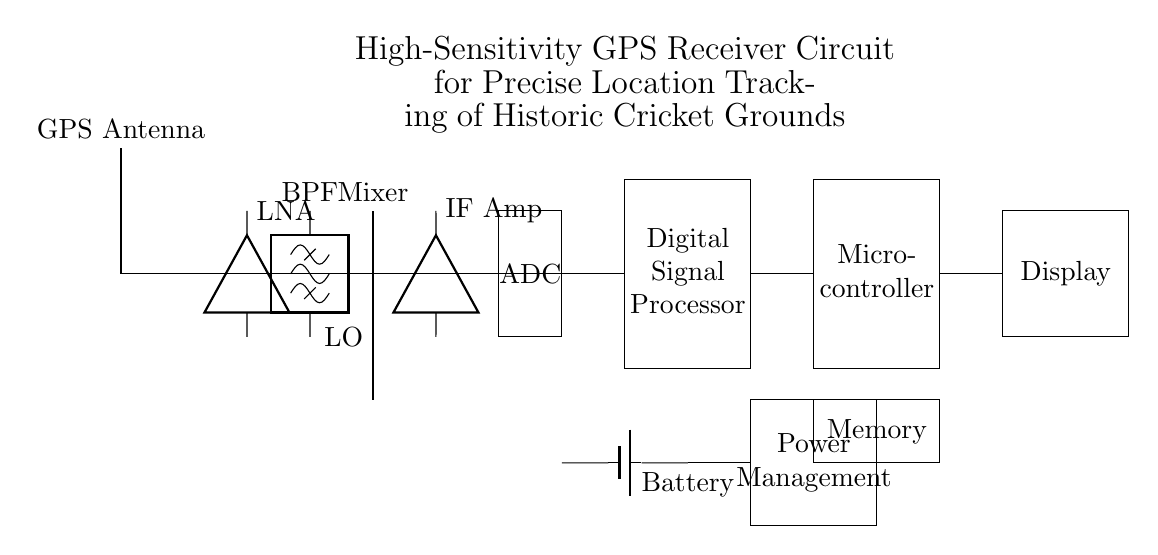What is the function of the LNA? The Low Noise Amplifier (LNA) is used to amplify the weak GPS signals received by the GPS antenna without adding significant noise. It ensures that the signals are strong enough for further processing in the circuit.
Answer: Amplification What type of filter is used in this circuit? The circuit includes a Bandpass Filter (BPF), which selectively allows the desired frequency range from the signals while rejecting others, thereby improving signal quality for further processing.
Answer: Bandpass Filter How many main components are in this GPS receiver circuit? The circuit diagram shows a total of eight main components: GPS Antenna, LNA, BPF, Mixer, Local Oscillator, IF Amplifier, ADC, Digital Signal Processor, and Microcontroller, along with supporting components like Memory, Display, and Power Management.
Answer: Eight Which component interfaces with the analog signals and digital systems? The ADC (Analog-to-Digital Converter) interfaces the analog signals from the IF Amplifier with the digital systems by converting those signals into a digital form for processing by the Digital Signal Processor and Microcontroller.
Answer: ADC What is the purpose of the Digital Signal Processor in the circuit? The Digital Signal Processor (DSP) processes the digitized GPS signals to extract useful location data. This includes filtering, decoding, and interpreting the signals for accurate positioning.
Answer: Signal processing What role does the Local Oscillator play in this circuit? The Local Oscillator generates a frequency used in the mixer stage to combine with incoming signals. This process shifts the frequency of the received signals down to an Intermediate Frequency (IF), making it easier to process.
Answer: Frequency generation Which component provides power to the entire circuit? The Battery is the main component that supplies power to the entire circuit, ensuring all other components operate as needed.
Answer: Battery 